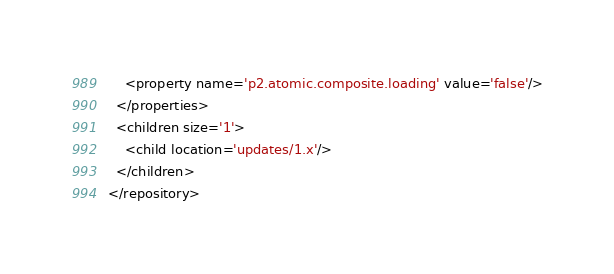<code> <loc_0><loc_0><loc_500><loc_500><_XML_>    <property name='p2.atomic.composite.loading' value='false'/>
  </properties>
  <children size='1'>
    <child location='updates/1.x'/>
  </children>
</repository>
</code> 